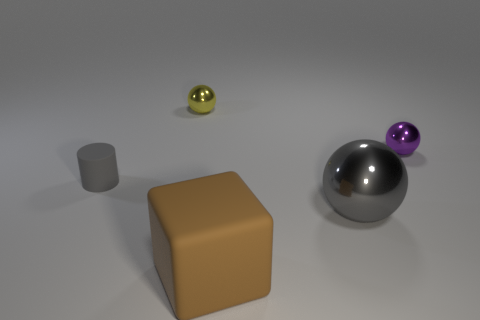Add 5 metal balls. How many objects exist? 10 Subtract all cylinders. How many objects are left? 4 Subtract 0 purple cylinders. How many objects are left? 5 Subtract all small shiny spheres. Subtract all balls. How many objects are left? 0 Add 5 yellow balls. How many yellow balls are left? 6 Add 1 gray shiny blocks. How many gray shiny blocks exist? 1 